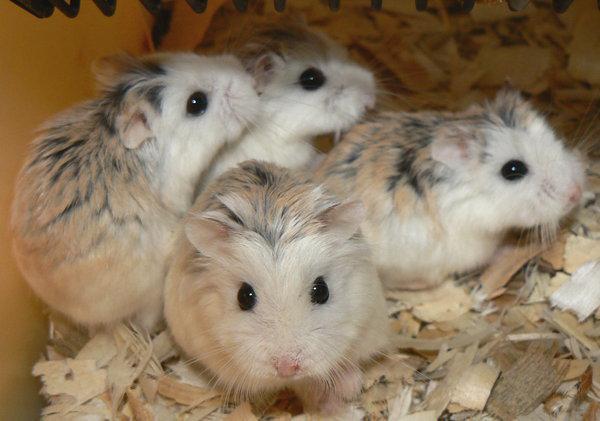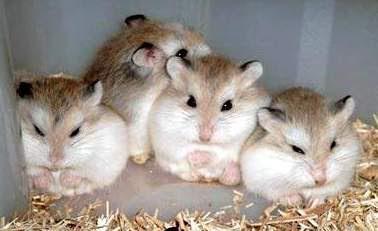The first image is the image on the left, the second image is the image on the right. Analyze the images presented: Is the assertion "The right image features exactly four hamsters." valid? Answer yes or no. Yes. 